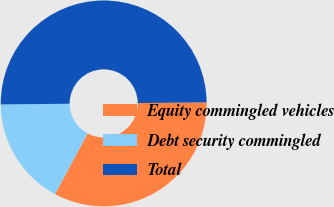<chart> <loc_0><loc_0><loc_500><loc_500><pie_chart><fcel>Equity commingled vehicles<fcel>Debt security commingled<fcel>Total<nl><fcel>33.0%<fcel>17.0%<fcel>50.0%<nl></chart> 